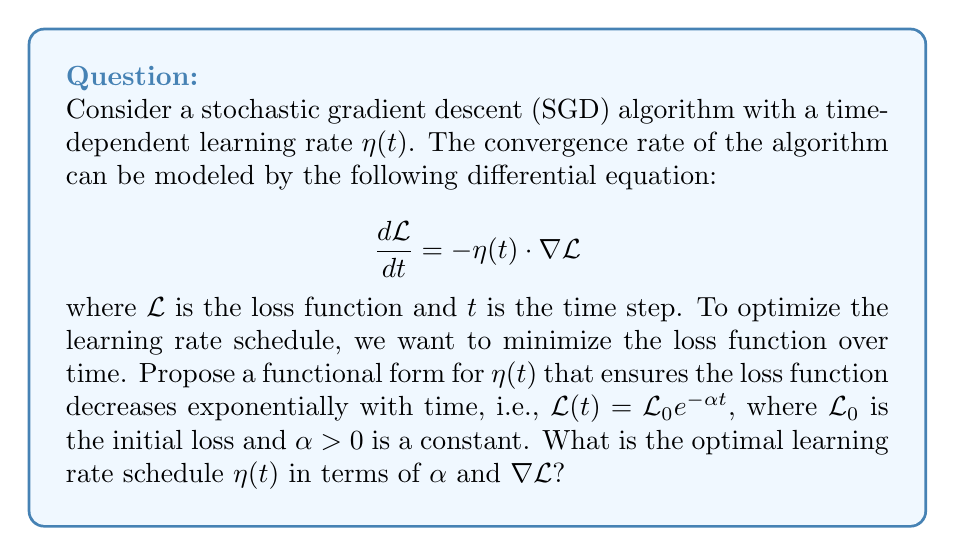Give your solution to this math problem. To solve this problem, we'll follow these steps:

1) We're given that the desired form of the loss function is:
   $$\mathcal{L}(t) = \mathcal{L}_0 e^{-\alpha t}$$

2) We need to find $\frac{d\mathcal{L}}{dt}$ for this function:
   $$\frac{d\mathcal{L}}{dt} = -\alpha \mathcal{L}_0 e^{-\alpha t} = -\alpha \mathcal{L}(t)$$

3) Now, we can equate this to the given differential equation:
   $$-\alpha \mathcal{L}(t) = -\eta(t) \cdot \nabla\mathcal{L}$$

4) Rearranging this equation:
   $$\eta(t) = \frac{\alpha \mathcal{L}(t)}{\nabla\mathcal{L}}$$

5) We know $\mathcal{L}(t) = \mathcal{L}_0 e^{-\alpha t}$, so we can substitute this:
   $$\eta(t) = \frac{\alpha \mathcal{L}_0 e^{-\alpha t}}{\nabla\mathcal{L}}$$

6) The gradient $\nabla\mathcal{L}$ is generally a function of $t$ as well. In a well-behaved optimization landscape, we expect the gradient to decrease as we approach the minimum. A reasonable assumption is that the gradient decreases proportionally to the loss function itself:
   $$\nabla\mathcal{L} \propto \mathcal{L}(t) = \mathcal{L}_0 e^{-\alpha t}$$

7) Let's say $\nabla\mathcal{L} = k\mathcal{L}_0 e^{-\alpha t}$, where $k$ is some constant of proportionality. Substituting this into our equation for $\eta(t)$:

   $$\eta(t) = \frac{\alpha \mathcal{L}_0 e^{-\alpha t}}{k\mathcal{L}_0 e^{-\alpha t}} = \frac{\alpha}{k}$$

This result shows that to achieve exponential decay of the loss function, the learning rate should actually be constant over time, with its value determined by the desired decay rate $\alpha$ and the proportionality constant $k$ relating the loss to its gradient.
Answer: The optimal learning rate schedule is a constant:

$$\eta(t) = \frac{\alpha}{k}$$

where $\alpha$ is the desired exponential decay rate of the loss function and $k$ is the proportionality constant between the loss and its gradient. 